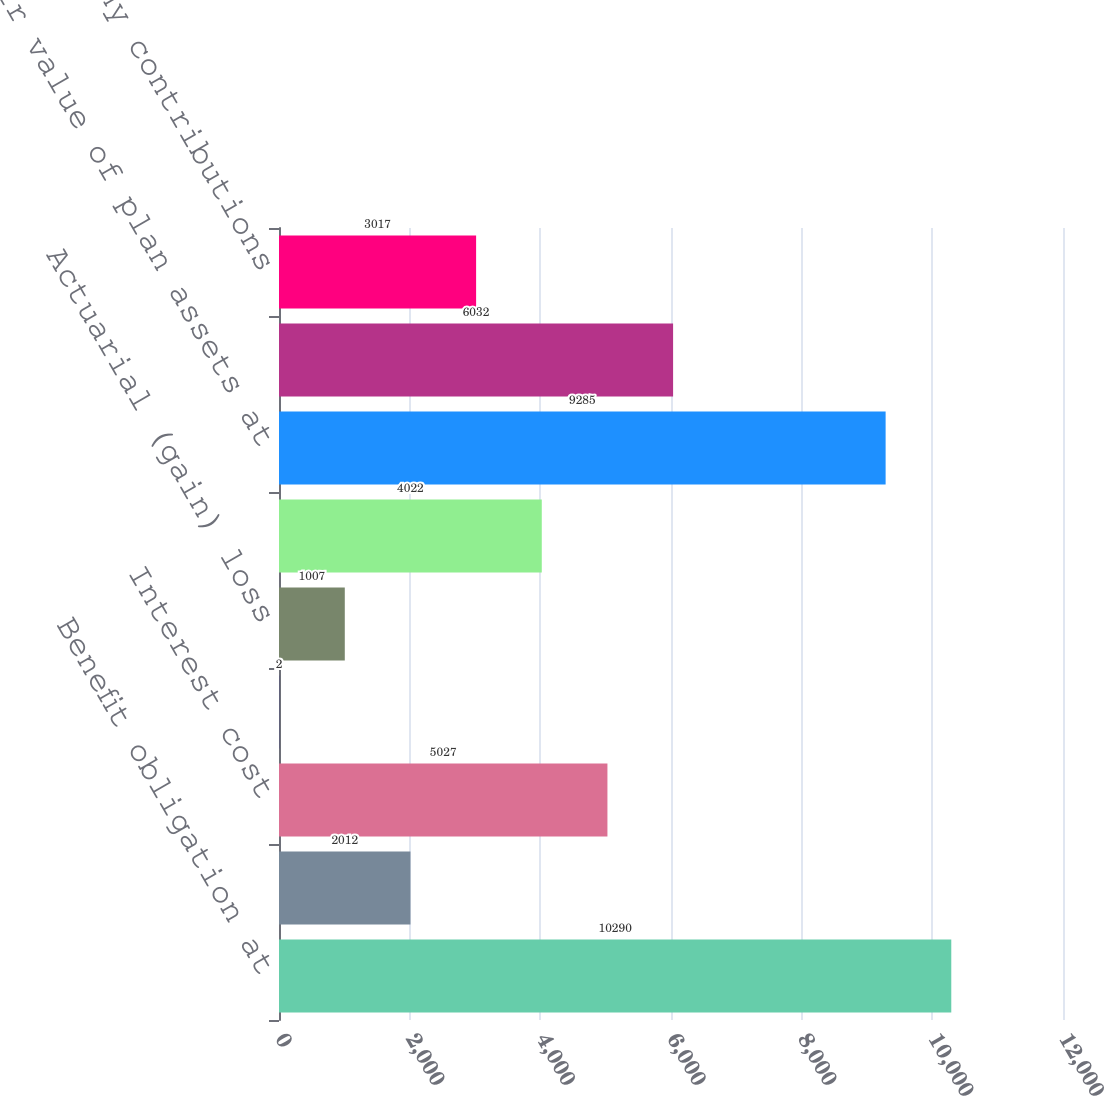Convert chart. <chart><loc_0><loc_0><loc_500><loc_500><bar_chart><fcel>Benefit obligation at<fcel>Service cost<fcel>Interest cost<fcel>Plan amendments<fcel>Actuarial (gain) loss<fcel>Benefit payments<fcel>Fair value of plan assets at<fcel>Actual return on plan assets<fcel>Company contributions<nl><fcel>10290<fcel>2012<fcel>5027<fcel>2<fcel>1007<fcel>4022<fcel>9285<fcel>6032<fcel>3017<nl></chart> 